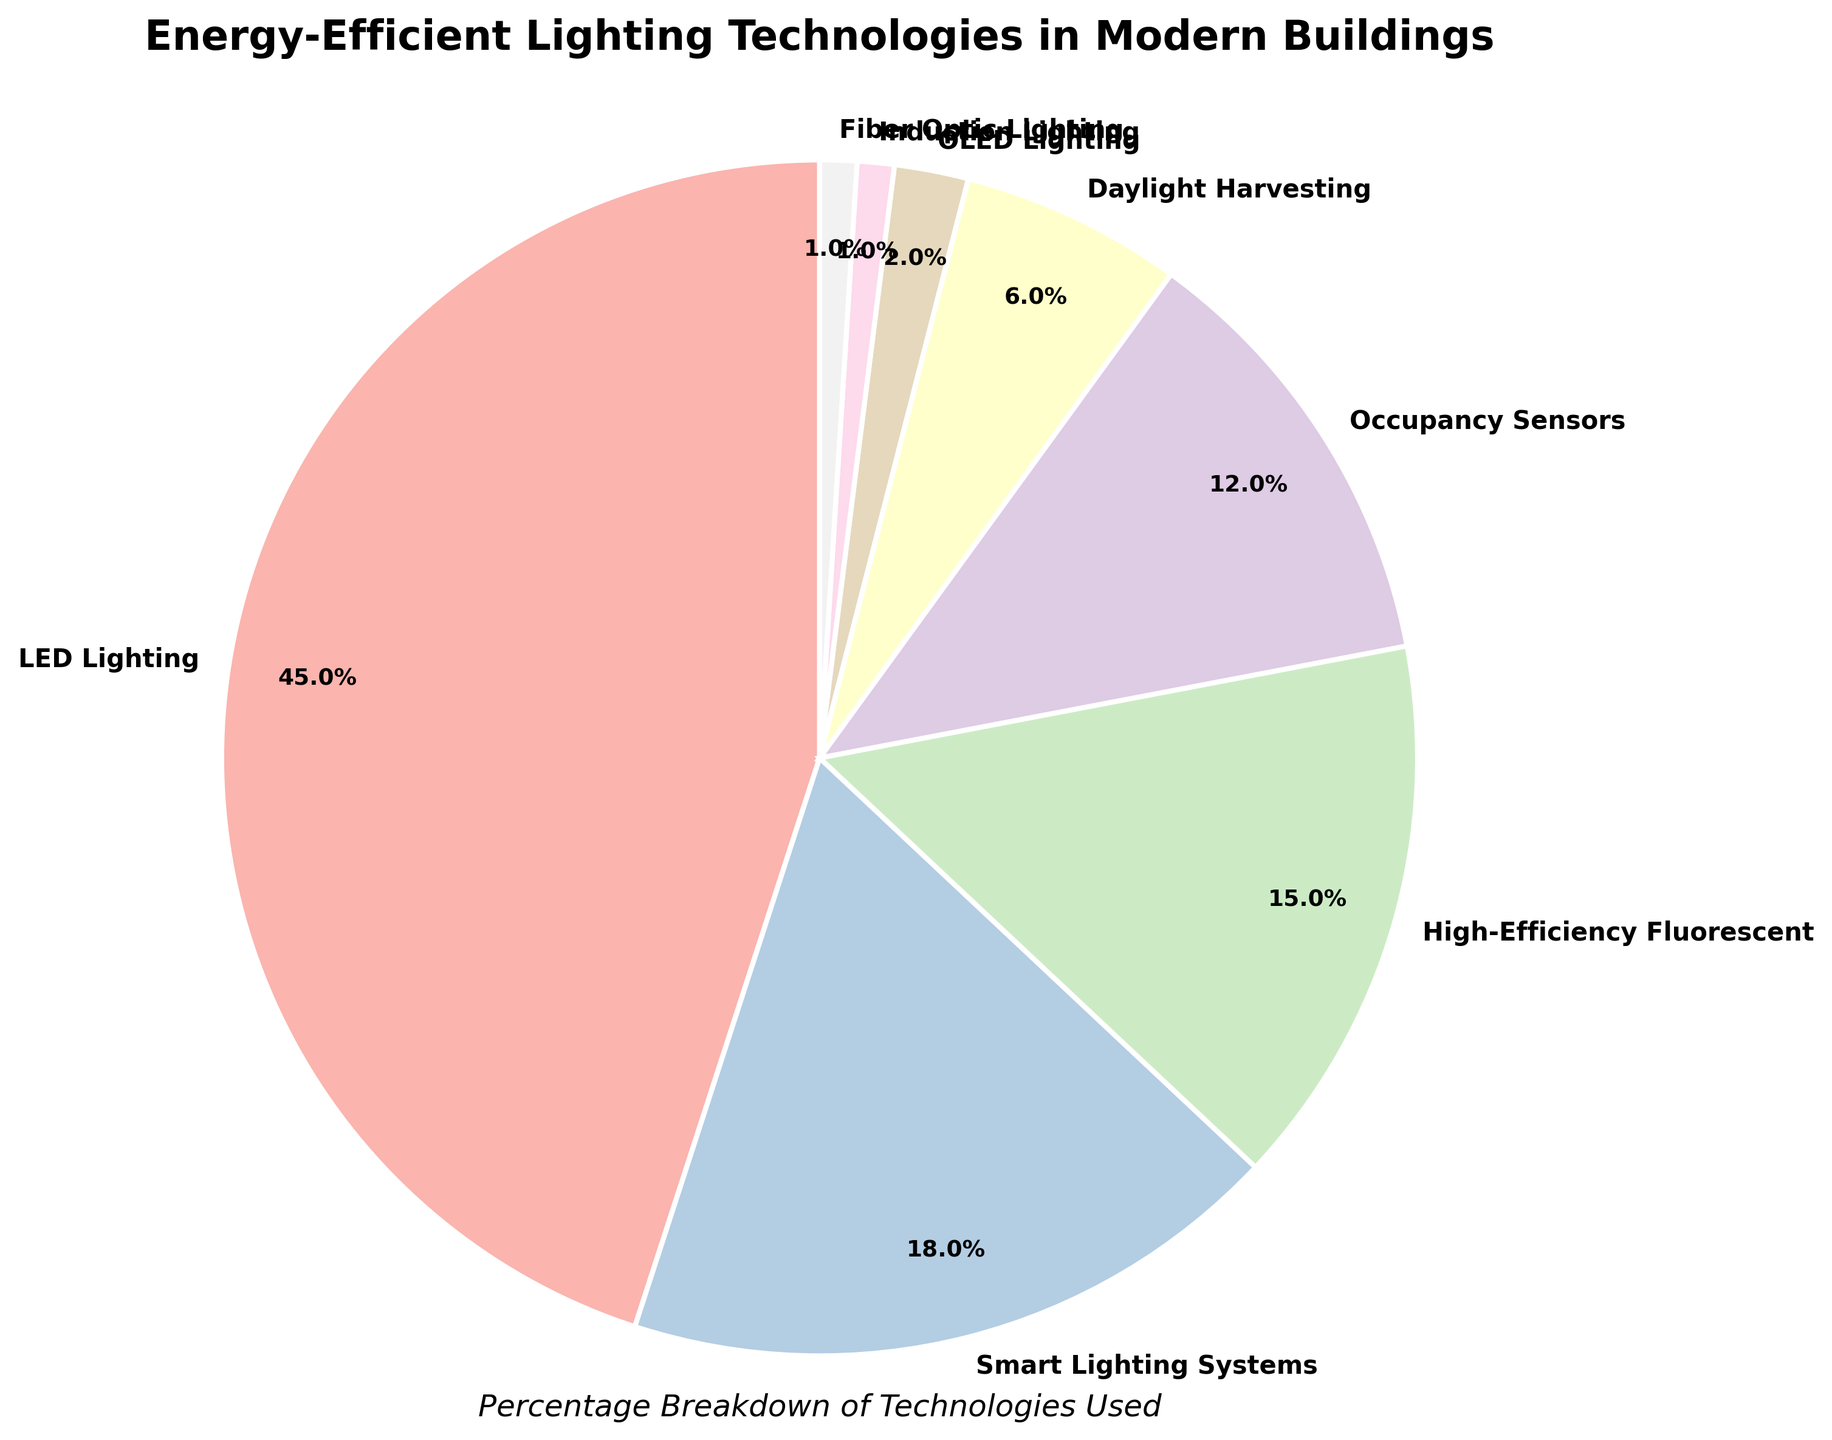What percentage of lighting technologies does LED Lighting encompass? To find the percentage of LED Lighting, look at the segment labeled "LED Lighting" in the pie chart. The value indicated is 45%.
Answer: 45% Which lighting technology has the second largest share? Identify the segment with the largest value excluding the highest one which is LED Lighting (45%). The segment labeled "Smart Lighting Systems" has the next largest value which is 18%.
Answer: Smart Lighting Systems Among the smallest segments (less than 5%), which technologies are indicated? Look for segments with values under 5%. The segments labeled "OLED Lighting", "Induction Lighting", and "Fiber Optic Lighting" are all under 5%, with values of 2%, 1%, and 1% respectively.
Answer: OLED Lighting, Induction Lighting, Fiber Optic Lighting What is the combined percentage of High-Efficiency Fluorescent and Occupancy Sensors? Add the percentages of High-Efficiency Fluorescent (15%) and Occupancy Sensors (12%). 15% + 12% = 27%.
Answer: 27% What is the total percentage for Daylight Harvesting and OLED Lighting? Add the percentages of Daylight Harvesting (6%) and OLED Lighting (2%). 6% + 2% = 8%.
Answer: 8% How much more percentage does LED Lighting have over High-Efficiency Fluorescent? Subtract the percentage of High-Efficiency Fluorescent (15%) from LED Lighting (45%). 45% - 15% = 30%.
Answer: 30% Is the combined share of Smart Lighting Systems and Occupancy Sensors greater than that of LED Lighting? Add the percentages of Smart Lighting Systems (18%) and Occupancy Sensors (12%), then compare the result to LED Lighting (45%). 18% + 12% = 30%, which is less than 45%.
Answer: No How does the percentage of Smart Lighting Systems compare to Daylight Harvesting? Compare the percentages of Smart Lighting Systems (18%) and Daylight Harvesting (6%). 18% is greater than 6%.
Answer: Smart Lighting Systems is greater What is the visual attribute of the segment representing Fiber Optic Lighting? Look at the segment labeled "Fiber Optic Lighting" in the pie chart. It uses a specific pastel color as part of a color palette. This color is similar in hue to other pale tones in the chart.
Answer: Pale pastel color 